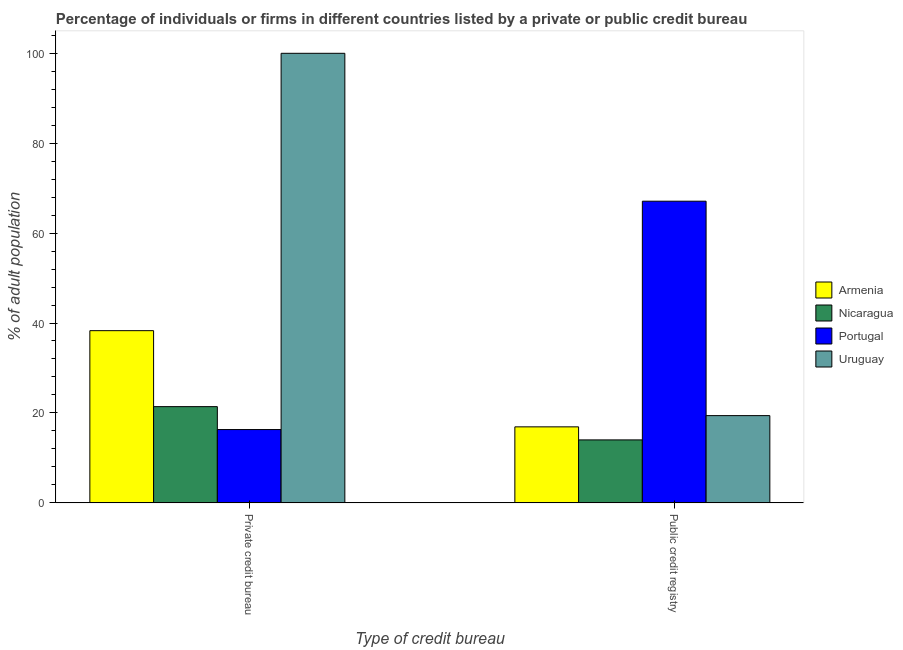Are the number of bars per tick equal to the number of legend labels?
Ensure brevity in your answer.  Yes. How many bars are there on the 1st tick from the left?
Ensure brevity in your answer.  4. How many bars are there on the 2nd tick from the right?
Keep it short and to the point. 4. What is the label of the 1st group of bars from the left?
Your answer should be very brief. Private credit bureau. What is the percentage of firms listed by public credit bureau in Nicaragua?
Your answer should be very brief. 14. Across all countries, what is the maximum percentage of firms listed by public credit bureau?
Your response must be concise. 67.1. Across all countries, what is the minimum percentage of firms listed by public credit bureau?
Provide a succinct answer. 14. In which country was the percentage of firms listed by private credit bureau maximum?
Provide a succinct answer. Uruguay. What is the total percentage of firms listed by private credit bureau in the graph?
Your response must be concise. 176. What is the difference between the percentage of firms listed by public credit bureau in Nicaragua and that in Uruguay?
Your answer should be very brief. -5.4. What is the difference between the percentage of firms listed by public credit bureau in Uruguay and the percentage of firms listed by private credit bureau in Portugal?
Your answer should be compact. 3.1. What is the average percentage of firms listed by public credit bureau per country?
Your response must be concise. 29.35. What is the difference between the percentage of firms listed by private credit bureau and percentage of firms listed by public credit bureau in Uruguay?
Ensure brevity in your answer.  80.6. In how many countries, is the percentage of firms listed by public credit bureau greater than 16 %?
Keep it short and to the point. 3. What is the ratio of the percentage of firms listed by public credit bureau in Portugal to that in Armenia?
Ensure brevity in your answer.  3.97. Is the percentage of firms listed by private credit bureau in Nicaragua less than that in Uruguay?
Your answer should be compact. Yes. What does the 1st bar from the left in Private credit bureau represents?
Ensure brevity in your answer.  Armenia. What does the 1st bar from the right in Private credit bureau represents?
Your answer should be compact. Uruguay. How many bars are there?
Provide a short and direct response. 8. How many countries are there in the graph?
Your answer should be very brief. 4. Does the graph contain grids?
Keep it short and to the point. No. Where does the legend appear in the graph?
Your response must be concise. Center right. How many legend labels are there?
Ensure brevity in your answer.  4. What is the title of the graph?
Provide a succinct answer. Percentage of individuals or firms in different countries listed by a private or public credit bureau. What is the label or title of the X-axis?
Your answer should be compact. Type of credit bureau. What is the label or title of the Y-axis?
Give a very brief answer. % of adult population. What is the % of adult population of Armenia in Private credit bureau?
Your answer should be compact. 38.3. What is the % of adult population in Nicaragua in Private credit bureau?
Ensure brevity in your answer.  21.4. What is the % of adult population in Portugal in Private credit bureau?
Your answer should be compact. 16.3. What is the % of adult population in Armenia in Public credit registry?
Provide a succinct answer. 16.9. What is the % of adult population of Portugal in Public credit registry?
Make the answer very short. 67.1. Across all Type of credit bureau, what is the maximum % of adult population of Armenia?
Ensure brevity in your answer.  38.3. Across all Type of credit bureau, what is the maximum % of adult population of Nicaragua?
Make the answer very short. 21.4. Across all Type of credit bureau, what is the maximum % of adult population of Portugal?
Keep it short and to the point. 67.1. Across all Type of credit bureau, what is the maximum % of adult population in Uruguay?
Offer a terse response. 100. Across all Type of credit bureau, what is the minimum % of adult population in Armenia?
Provide a succinct answer. 16.9. Across all Type of credit bureau, what is the minimum % of adult population of Portugal?
Your answer should be very brief. 16.3. Across all Type of credit bureau, what is the minimum % of adult population in Uruguay?
Give a very brief answer. 19.4. What is the total % of adult population of Armenia in the graph?
Keep it short and to the point. 55.2. What is the total % of adult population of Nicaragua in the graph?
Make the answer very short. 35.4. What is the total % of adult population of Portugal in the graph?
Make the answer very short. 83.4. What is the total % of adult population in Uruguay in the graph?
Offer a very short reply. 119.4. What is the difference between the % of adult population in Armenia in Private credit bureau and that in Public credit registry?
Offer a terse response. 21.4. What is the difference between the % of adult population in Portugal in Private credit bureau and that in Public credit registry?
Provide a short and direct response. -50.8. What is the difference between the % of adult population of Uruguay in Private credit bureau and that in Public credit registry?
Provide a succinct answer. 80.6. What is the difference between the % of adult population in Armenia in Private credit bureau and the % of adult population in Nicaragua in Public credit registry?
Offer a terse response. 24.3. What is the difference between the % of adult population of Armenia in Private credit bureau and the % of adult population of Portugal in Public credit registry?
Your response must be concise. -28.8. What is the difference between the % of adult population in Nicaragua in Private credit bureau and the % of adult population in Portugal in Public credit registry?
Give a very brief answer. -45.7. What is the difference between the % of adult population in Portugal in Private credit bureau and the % of adult population in Uruguay in Public credit registry?
Provide a short and direct response. -3.1. What is the average % of adult population of Armenia per Type of credit bureau?
Your answer should be compact. 27.6. What is the average % of adult population of Portugal per Type of credit bureau?
Offer a very short reply. 41.7. What is the average % of adult population in Uruguay per Type of credit bureau?
Keep it short and to the point. 59.7. What is the difference between the % of adult population in Armenia and % of adult population in Uruguay in Private credit bureau?
Give a very brief answer. -61.7. What is the difference between the % of adult population in Nicaragua and % of adult population in Portugal in Private credit bureau?
Offer a very short reply. 5.1. What is the difference between the % of adult population in Nicaragua and % of adult population in Uruguay in Private credit bureau?
Provide a short and direct response. -78.6. What is the difference between the % of adult population of Portugal and % of adult population of Uruguay in Private credit bureau?
Offer a very short reply. -83.7. What is the difference between the % of adult population in Armenia and % of adult population in Portugal in Public credit registry?
Ensure brevity in your answer.  -50.2. What is the difference between the % of adult population in Nicaragua and % of adult population in Portugal in Public credit registry?
Keep it short and to the point. -53.1. What is the difference between the % of adult population in Nicaragua and % of adult population in Uruguay in Public credit registry?
Offer a very short reply. -5.4. What is the difference between the % of adult population in Portugal and % of adult population in Uruguay in Public credit registry?
Your answer should be compact. 47.7. What is the ratio of the % of adult population in Armenia in Private credit bureau to that in Public credit registry?
Your answer should be compact. 2.27. What is the ratio of the % of adult population of Nicaragua in Private credit bureau to that in Public credit registry?
Make the answer very short. 1.53. What is the ratio of the % of adult population of Portugal in Private credit bureau to that in Public credit registry?
Offer a very short reply. 0.24. What is the ratio of the % of adult population of Uruguay in Private credit bureau to that in Public credit registry?
Offer a very short reply. 5.15. What is the difference between the highest and the second highest % of adult population of Armenia?
Make the answer very short. 21.4. What is the difference between the highest and the second highest % of adult population of Nicaragua?
Keep it short and to the point. 7.4. What is the difference between the highest and the second highest % of adult population of Portugal?
Your answer should be very brief. 50.8. What is the difference between the highest and the second highest % of adult population in Uruguay?
Keep it short and to the point. 80.6. What is the difference between the highest and the lowest % of adult population of Armenia?
Your answer should be compact. 21.4. What is the difference between the highest and the lowest % of adult population in Nicaragua?
Your response must be concise. 7.4. What is the difference between the highest and the lowest % of adult population of Portugal?
Provide a succinct answer. 50.8. What is the difference between the highest and the lowest % of adult population of Uruguay?
Your answer should be compact. 80.6. 